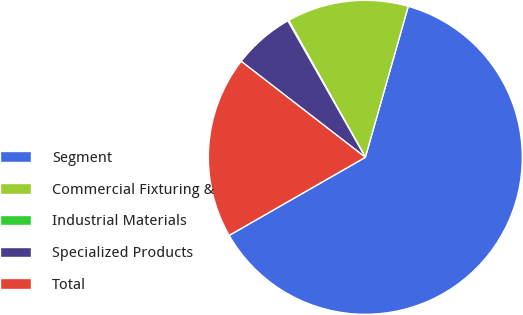Convert chart. <chart><loc_0><loc_0><loc_500><loc_500><pie_chart><fcel>Segment<fcel>Commercial Fixturing &<fcel>Industrial Materials<fcel>Specialized Products<fcel>Total<nl><fcel>62.3%<fcel>12.53%<fcel>0.09%<fcel>6.31%<fcel>18.76%<nl></chart> 